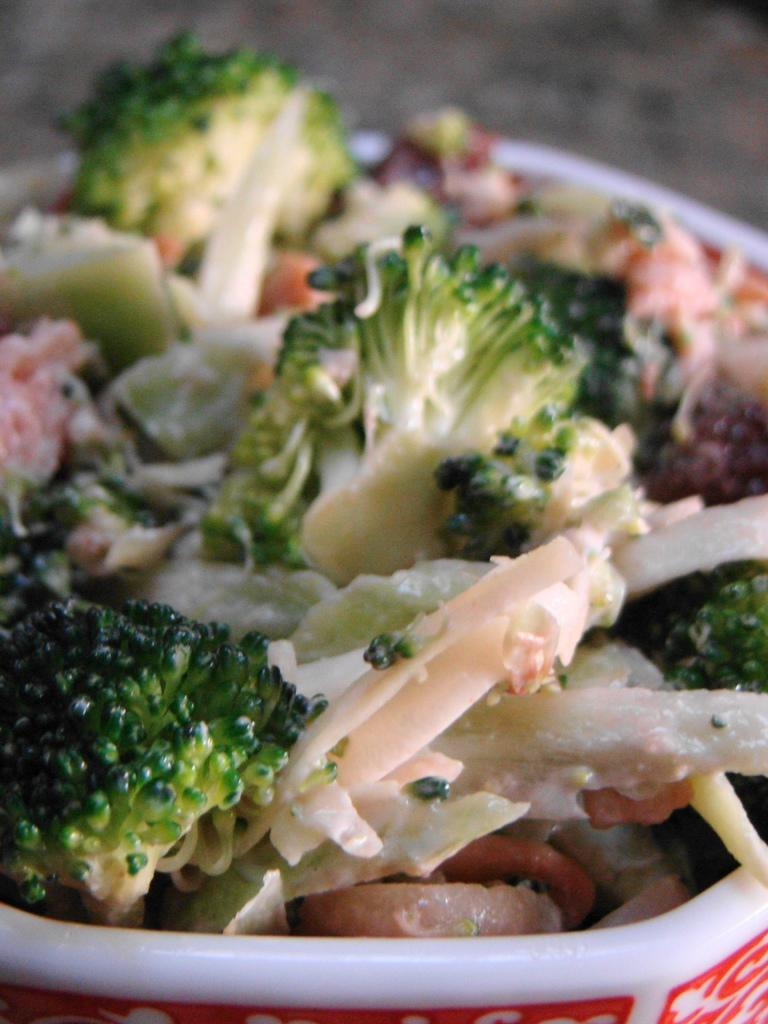What object is present in the image that can hold items? There is a bucket in the image. What is inside the bucket? The bucket contains broccoli. Are there any other items in the bucket besides broccoli? Yes, there are other items of white and brown color in the bucket. How would you describe the background of the image? The background of the image is blurred. Can you see any fish swimming in the bucket? No, there are no fish present in the image. The bucket contains broccoli and other items of white and brown color. 